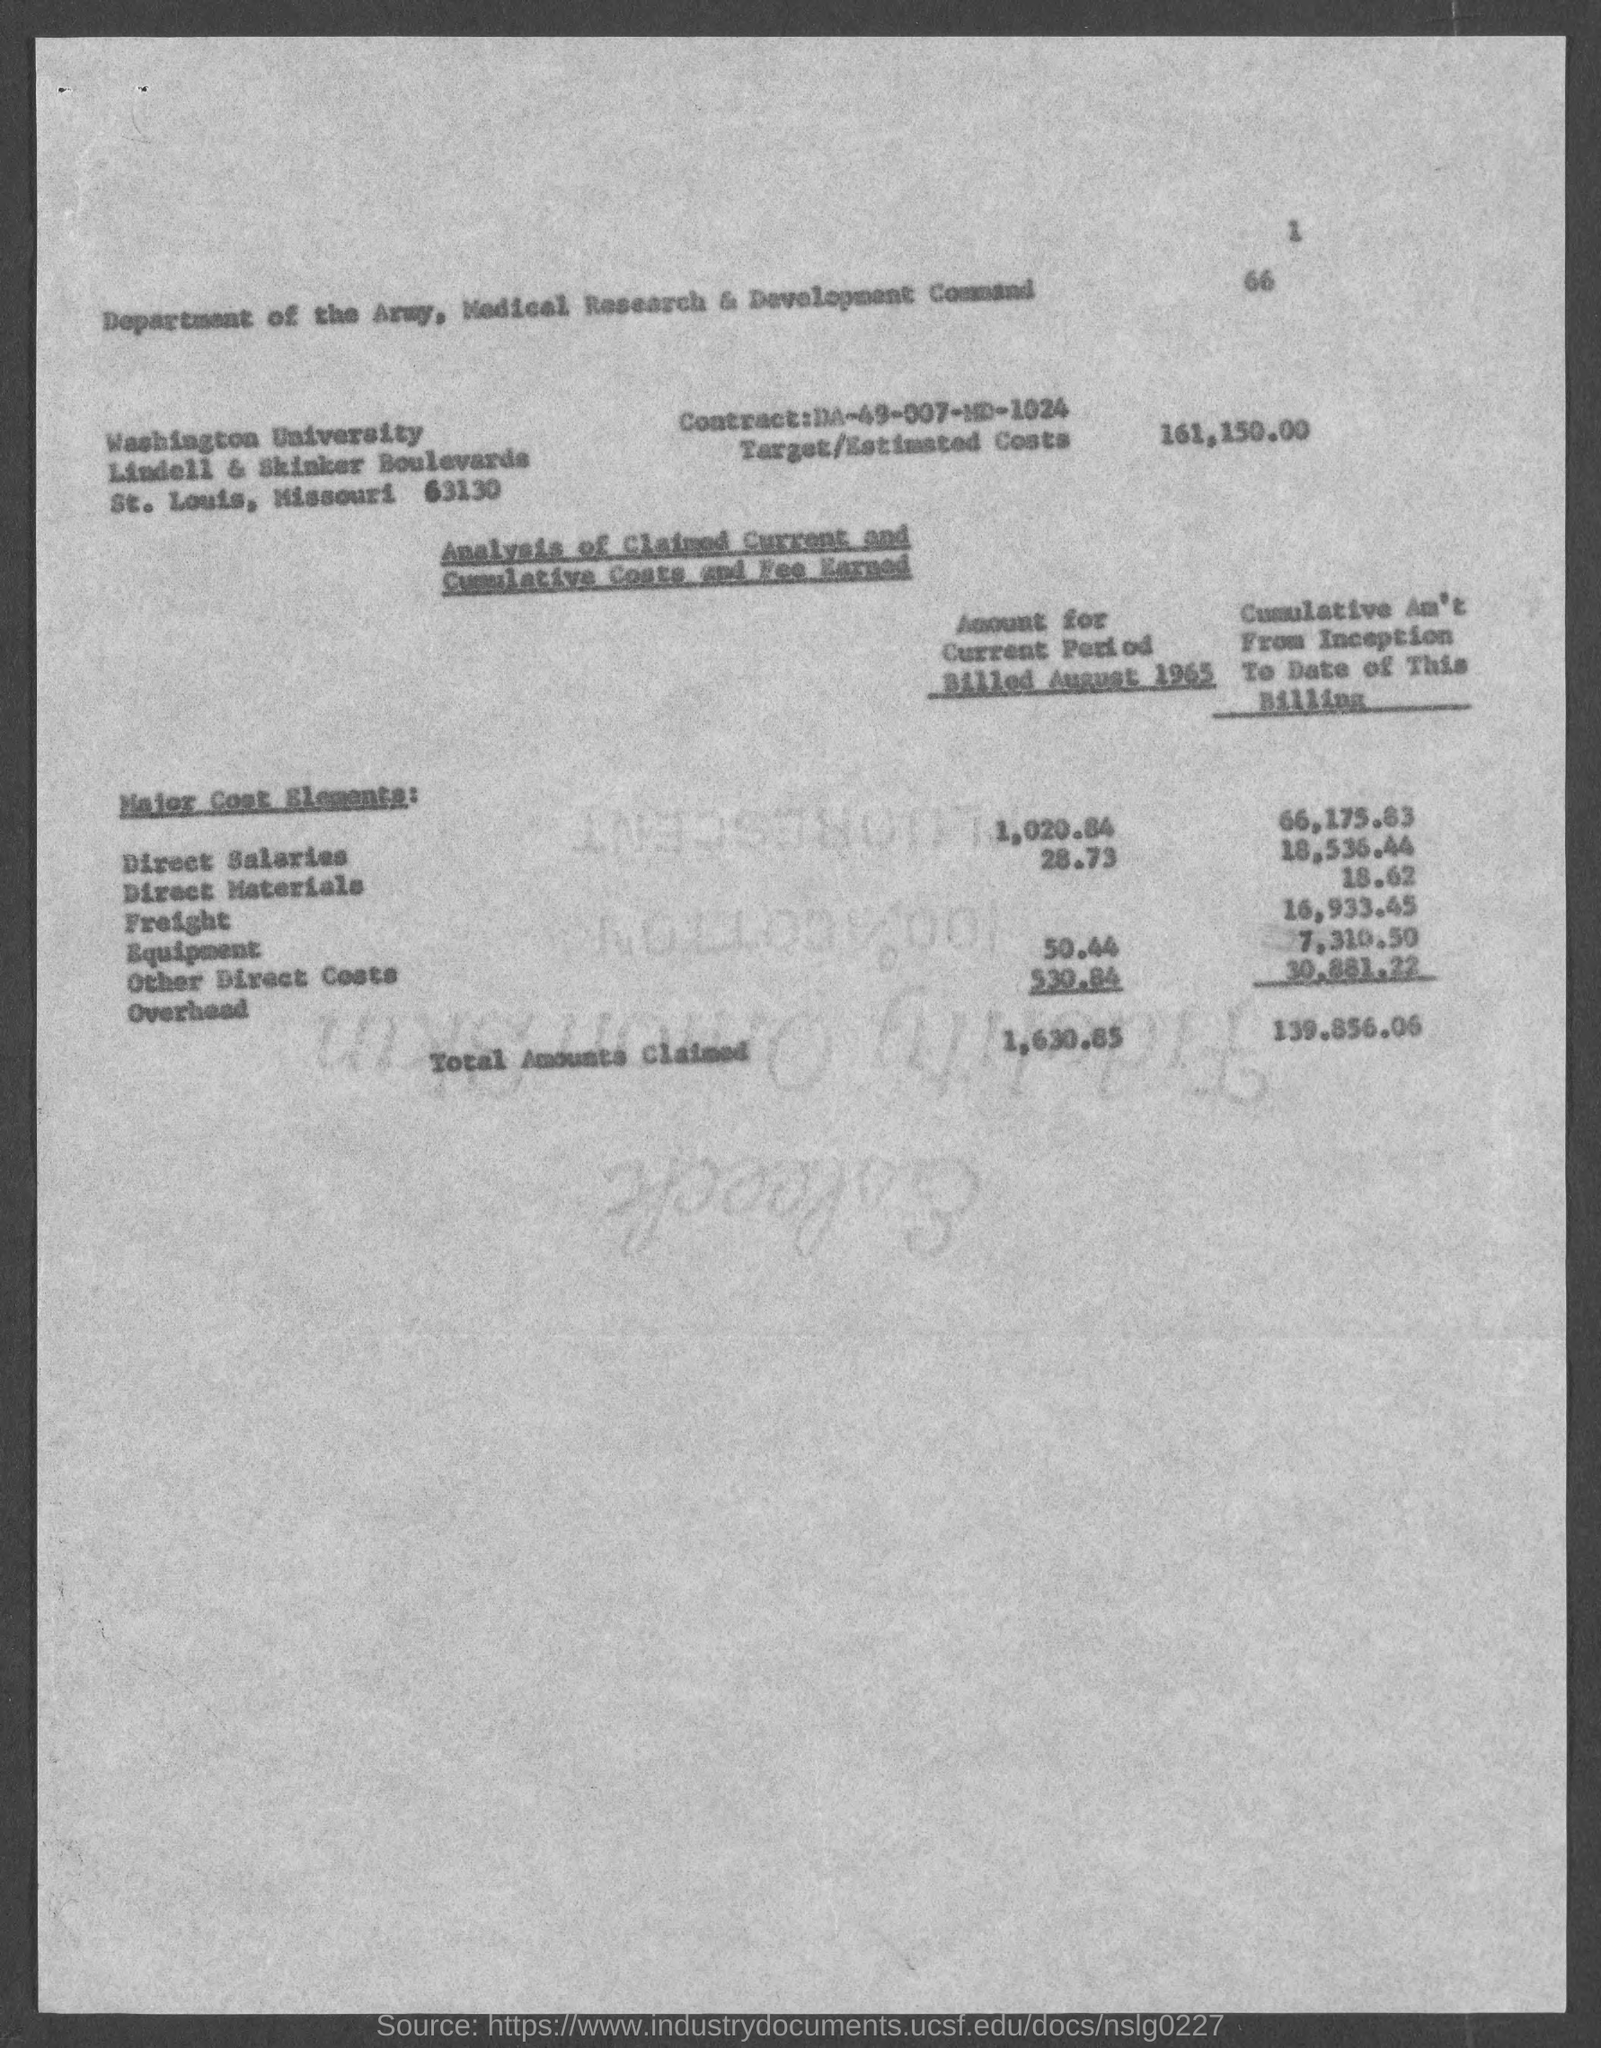What is the Contract No. given in the document?
Ensure brevity in your answer.  DA-49-007-MD-1024. What is the Target/Estimated costs given in the document?
Give a very brief answer. 161,150.00. What is the total cumulative amount claimed from inception to date of this billing?
Offer a very short reply. 139,856.06. What is the direct materials amount for the current period billed in August 1965?
Keep it short and to the point. 28.73. What is the direct salaries amount for the current period billed in August 1965?
Offer a terse response. 1,020.84. What is the cumulative amount for equipment from inception to date of this billing?
Provide a succinct answer. 16,933.45. What is the cumulative amount for Freight from inception to date of this billing?
Make the answer very short. 18.62. What is the overhead cost for the current period billed in August 1965?
Provide a short and direct response. 530.84. 